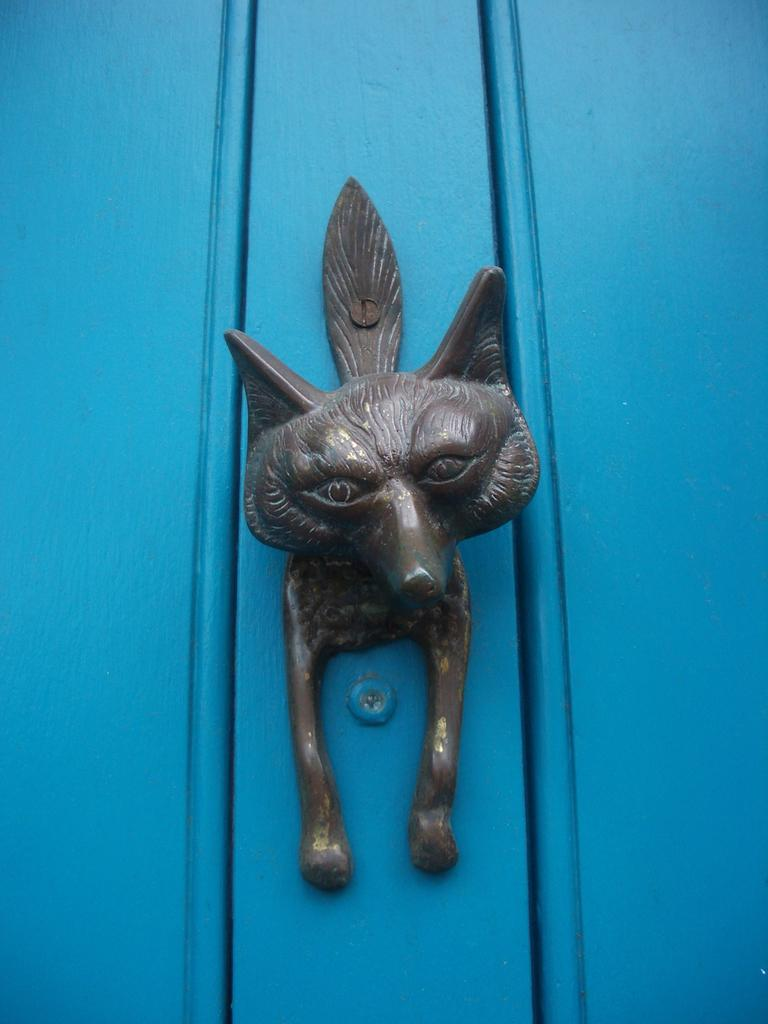What is the main subject in the center of the image? There is a toy in the center of the image. Can you describe anything in the background of the image? There is a door in the background of the image. What is the name of the mist that surrounds the toy in the image? There is no mist present in the image; it is a toy in the center of the image with a door in the background. 